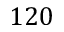Convert formula to latex. <formula><loc_0><loc_0><loc_500><loc_500>1 2 0</formula> 